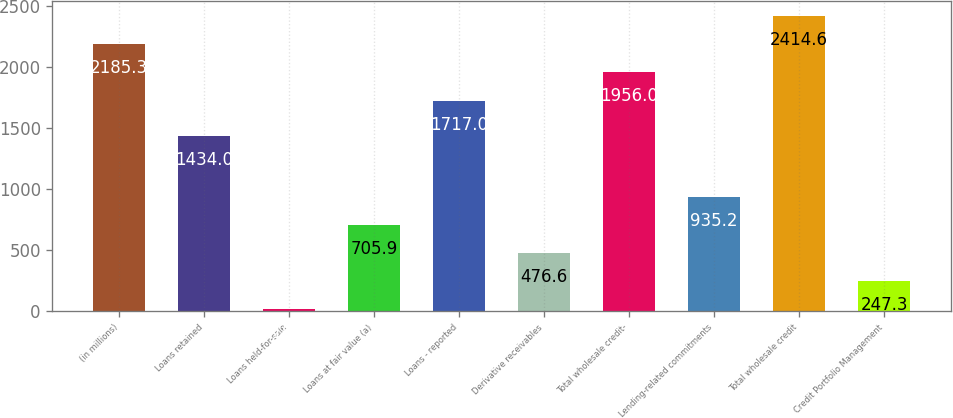<chart> <loc_0><loc_0><loc_500><loc_500><bar_chart><fcel>(in millions)<fcel>Loans retained<fcel>Loans held-for-sale<fcel>Loans at fair value (a)<fcel>Loans - reported<fcel>Derivative receivables<fcel>Total wholesale credit-<fcel>Lending-related commitments<fcel>Total wholesale credit<fcel>Credit Portfolio Management<nl><fcel>2185.3<fcel>1434<fcel>18<fcel>705.9<fcel>1717<fcel>476.6<fcel>1956<fcel>935.2<fcel>2414.6<fcel>247.3<nl></chart> 